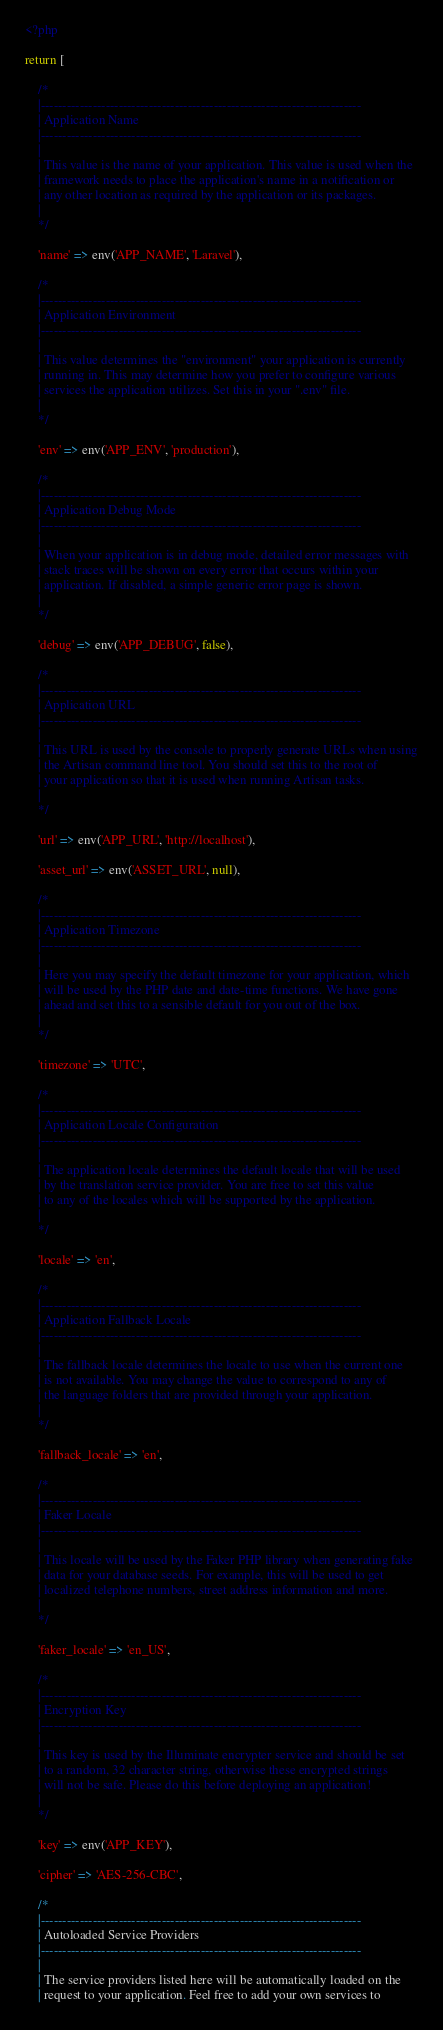<code> <loc_0><loc_0><loc_500><loc_500><_PHP_><?php

return [

    /*
    |--------------------------------------------------------------------------
    | Application Name
    |--------------------------------------------------------------------------
    |
    | This value is the name of your application. This value is used when the
    | framework needs to place the application's name in a notification or
    | any other location as required by the application or its packages.
    |
    */

    'name' => env('APP_NAME', 'Laravel'),

    /*
    |--------------------------------------------------------------------------
    | Application Environment
    |--------------------------------------------------------------------------
    |
    | This value determines the "environment" your application is currently
    | running in. This may determine how you prefer to configure various
    | services the application utilizes. Set this in your ".env" file.
    |
    */

    'env' => env('APP_ENV', 'production'),

    /*
    |--------------------------------------------------------------------------
    | Application Debug Mode
    |--------------------------------------------------------------------------
    |
    | When your application is in debug mode, detailed error messages with
    | stack traces will be shown on every error that occurs within your
    | application. If disabled, a simple generic error page is shown.
    |
    */

    'debug' => env('APP_DEBUG', false),

    /*
    |--------------------------------------------------------------------------
    | Application URL
    |--------------------------------------------------------------------------
    |
    | This URL is used by the console to properly generate URLs when using
    | the Artisan command line tool. You should set this to the root of
    | your application so that it is used when running Artisan tasks.
    |
    */

    'url' => env('APP_URL', 'http://localhost'),

    'asset_url' => env('ASSET_URL', null),

    /*
    |--------------------------------------------------------------------------
    | Application Timezone
    |--------------------------------------------------------------------------
    |
    | Here you may specify the default timezone for your application, which
    | will be used by the PHP date and date-time functions. We have gone
    | ahead and set this to a sensible default for you out of the box.
    |
    */

    'timezone' => 'UTC',

    /*
    |--------------------------------------------------------------------------
    | Application Locale Configuration
    |--------------------------------------------------------------------------
    |
    | The application locale determines the default locale that will be used
    | by the translation service provider. You are free to set this value
    | to any of the locales which will be supported by the application.
    |
    */

    'locale' => 'en',

    /*
    |--------------------------------------------------------------------------
    | Application Fallback Locale
    |--------------------------------------------------------------------------
    |
    | The fallback locale determines the locale to use when the current one
    | is not available. You may change the value to correspond to any of
    | the language folders that are provided through your application.
    |
    */

    'fallback_locale' => 'en',

    /*
    |--------------------------------------------------------------------------
    | Faker Locale
    |--------------------------------------------------------------------------
    |
    | This locale will be used by the Faker PHP library when generating fake
    | data for your database seeds. For example, this will be used to get
    | localized telephone numbers, street address information and more.
    |
    */

    'faker_locale' => 'en_US',

    /*
    |--------------------------------------------------------------------------
    | Encryption Key
    |--------------------------------------------------------------------------
    |
    | This key is used by the Illuminate encrypter service and should be set
    | to a random, 32 character string, otherwise these encrypted strings
    | will not be safe. Please do this before deploying an application!
    |
    */

    'key' => env('APP_KEY'),

    'cipher' => 'AES-256-CBC',

    /*
    |--------------------------------------------------------------------------
    | Autoloaded Service Providers
    |--------------------------------------------------------------------------
    |
    | The service providers listed here will be automatically loaded on the
    | request to your application. Feel free to add your own services to</code> 